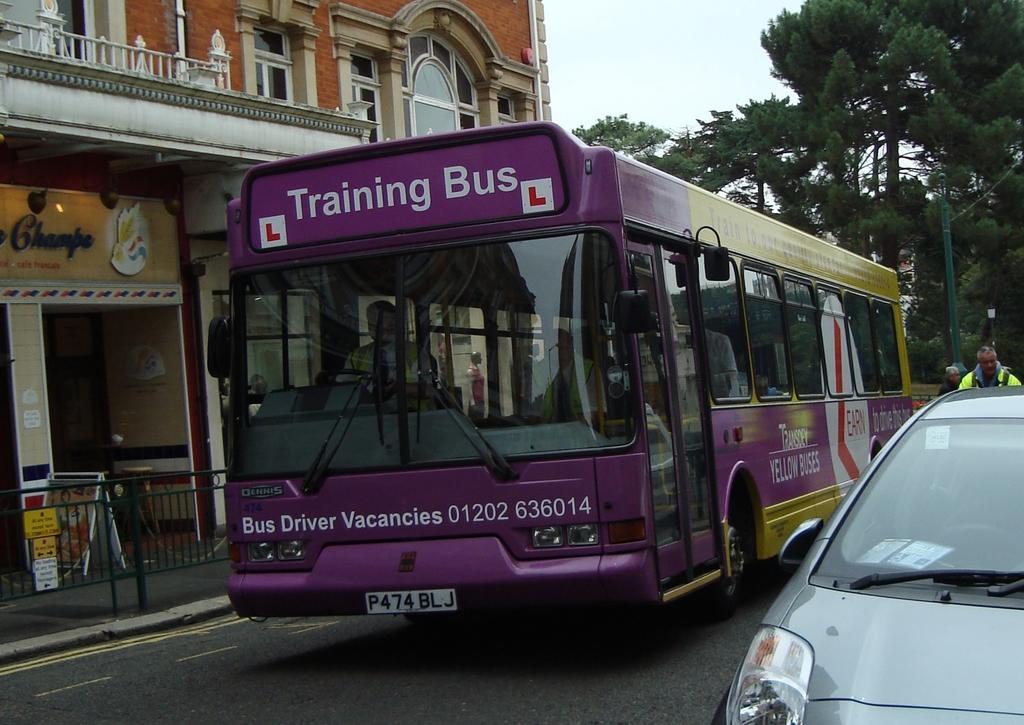Could you give a brief overview of what you see in this image? In this picture there is a bus in the center of the image and there is a car on the right side of the image and there are trees on the right side of the image, there is a building and a boundary on the left side of the image. 